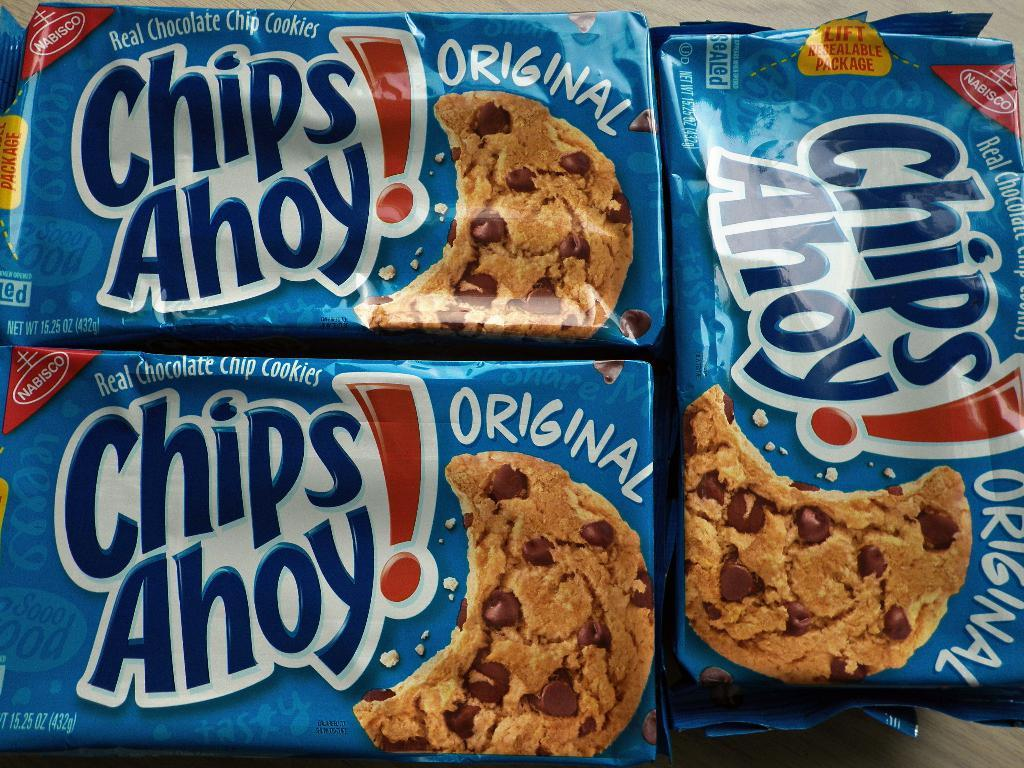What is present on the table in the image? There are cookies packets on the table in the image. Can you describe the cookies packets in more detail? The cookies packets are the main subject visible on the table. How many clams are visible on the table in the image? There are no clams present in the image; it only features cookies packets on a table. 